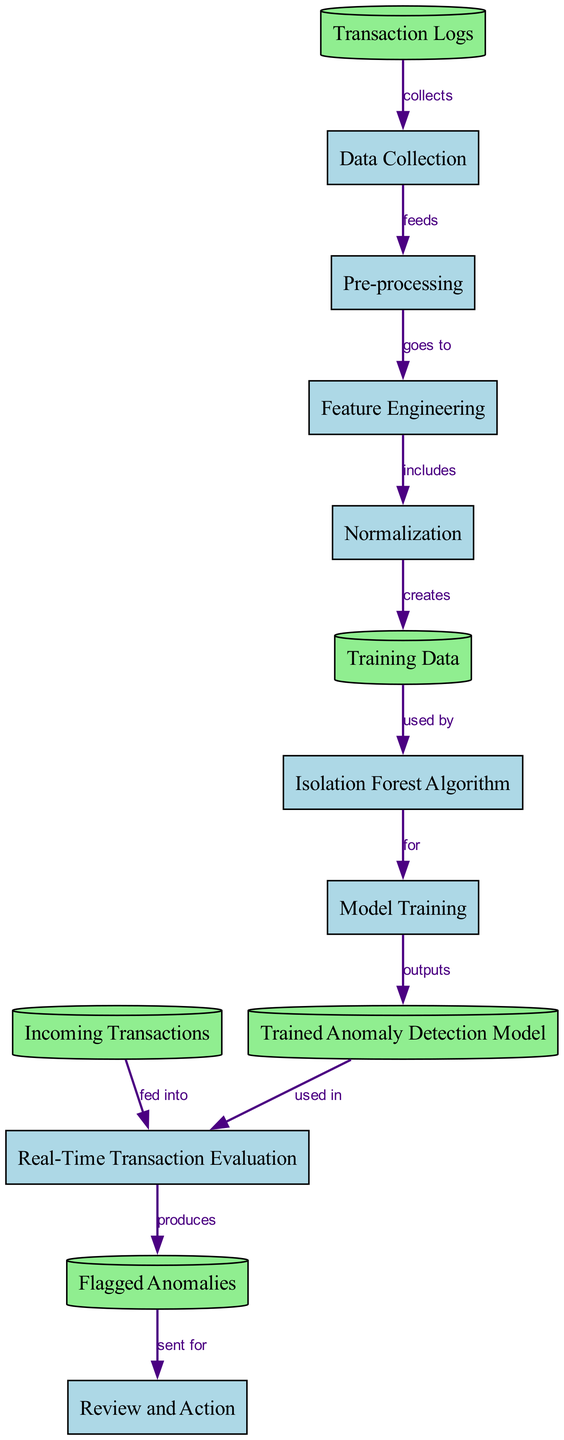What is the initial input to the diagram? The initial input is the "Transaction Logs," which is the first node that collects data before it enters the "Data Collection" process.
Answer: Transaction Logs How many processes are present in the diagram? By counting the nodes labeled as "process," we see there are seven processes listed: Data Collection, Pre-processing, Feature Engineering, Normalization, Isolation Forest Algorithm, Model Training, and Review and Action.
Answer: Seven What data is created by the Normalization process? The "Normalization" process creates "Training Data," as indicated by the edge leading from Normalization to Training Data.
Answer: Training Data Which node indicates the output of the anomaly detection process? The output of the anomaly detection process is represented by the node "Flagged Anomalies," which results from the evaluation of real-time transactions.
Answer: Flagged Anomalies What process follows the "Real-Time Transaction Evaluation"? After real-time transactions are evaluated, they produce "Flagged Anomalies," which is the next step in the workflow.
Answer: Flagged Anomalies Which node is used in the Real-Time Transaction Evaluation? The "Trained Anomaly Detection Model" is used during the "Real-Time Transaction Evaluation" as indicated by the directed edge connecting them in the diagram.
Answer: Trained Anomaly Detection Model What type of data does the "Data Collection" node represent? The "Data Collection" node represents the data type "process," which indicates it is part of a functional sequence in this workflow.
Answer: Process What connection type is represented by the edge from "Training Data" to "Isolation Forest Algorithm"? The edge from "Training Data" to "Isolation Forest Algorithm" is labeled as "used by," highlighting the relationship in which the Training Data is utilized within the Isolation Forest algorithm process.
Answer: Used by What process follows the "Model Training" in the diagram? The process that follows "Model Training" is the output of the trained anomaly detection model, indicating a sequential flow in the pipeline following training.
Answer: Trained Anomaly Detection Model 